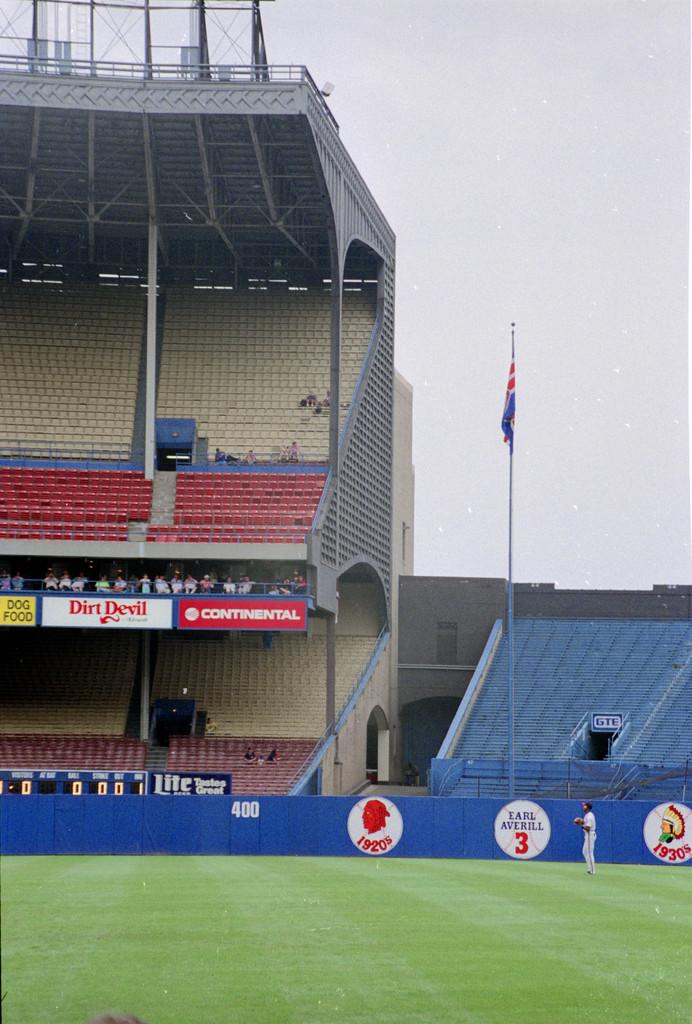What is one of the large brands visible?
Keep it short and to the point. Dirt devil. 